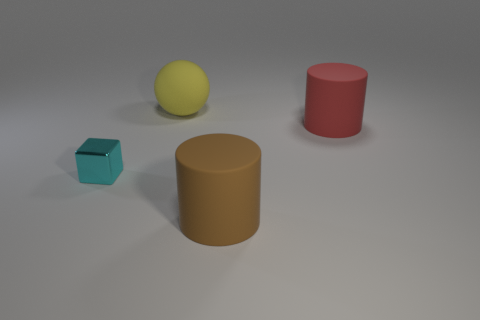Add 4 rubber things. How many objects exist? 8 Subtract all balls. How many objects are left? 3 Subtract all yellow matte balls. Subtract all big matte cylinders. How many objects are left? 1 Add 3 large matte cylinders. How many large matte cylinders are left? 5 Add 1 large yellow shiny spheres. How many large yellow shiny spheres exist? 1 Subtract 0 purple cubes. How many objects are left? 4 